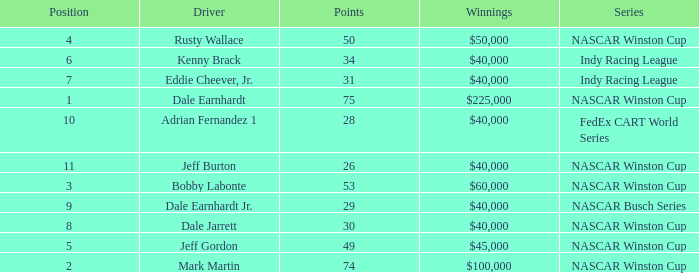What position did the driver earn 31 points? 7.0. 